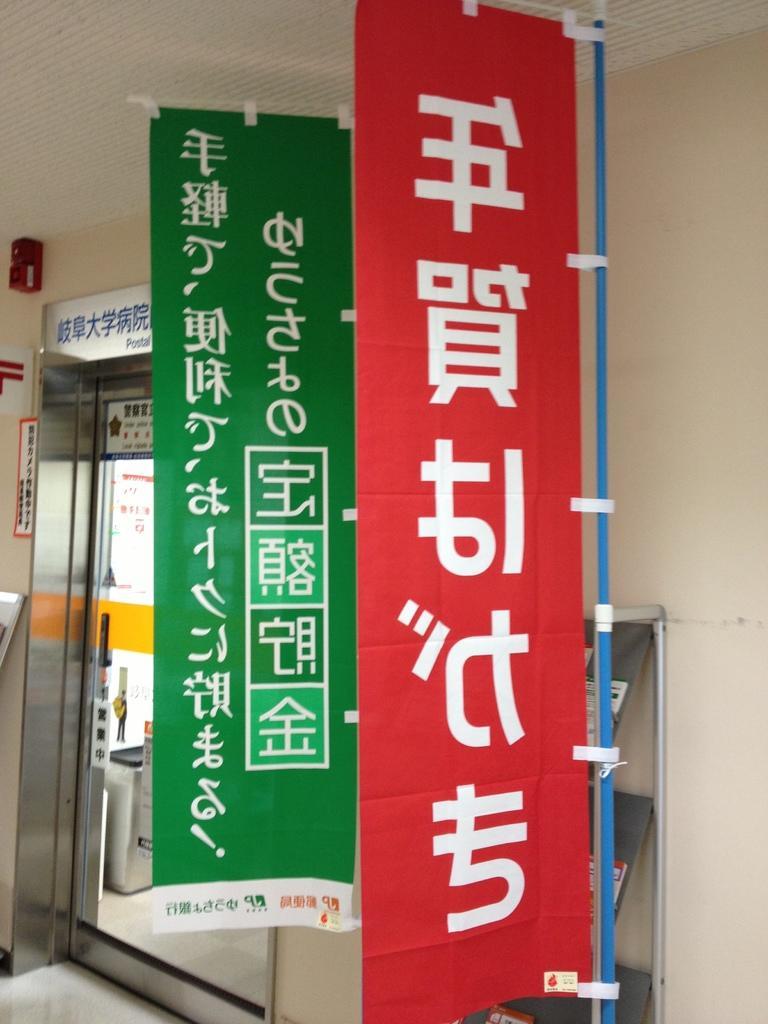In one or two sentences, can you explain what this image depicts? On the right side these are the two clothes in red color and green color. On the left side there is a glass wall. 